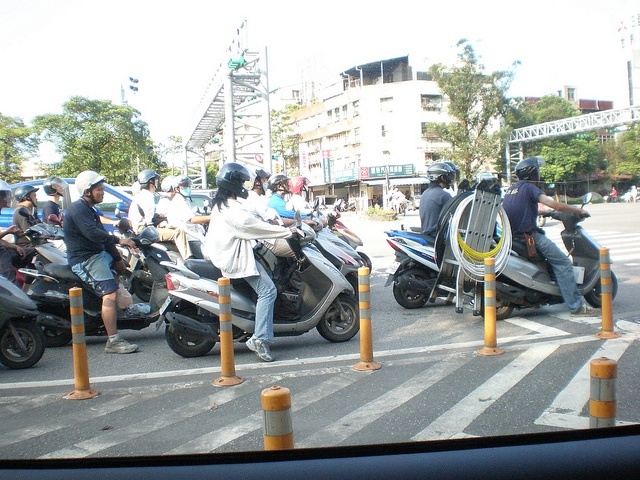Describe the objects in this image and their specific colors. I can see motorcycle in white, black, gray, and darkgray tones, motorcycle in white, black, gray, darkgray, and blue tones, people in white, darkgray, and gray tones, motorcycle in white, gray, black, darkgray, and purple tones, and people in white, black, gray, blue, and navy tones in this image. 